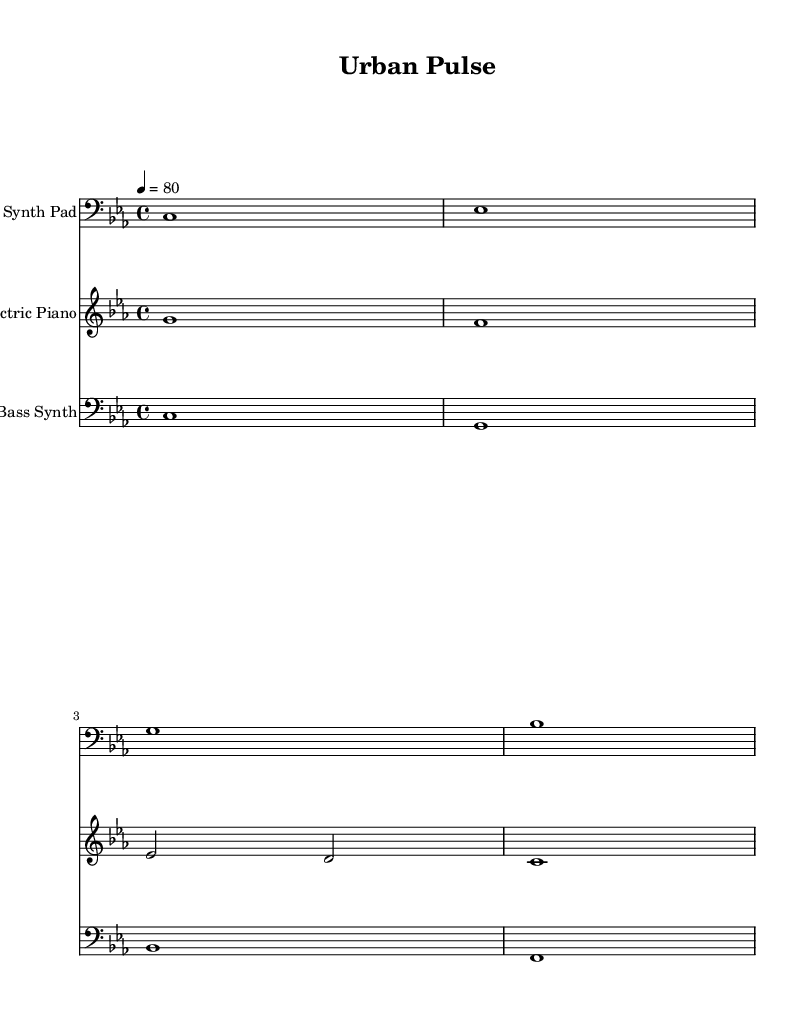What is the key signature of this music? The key signature is C minor, which has three flats (B flat, E flat, and A flat). This can be identified by looking at the key signature at the beginning of the staff.
Answer: C minor What is the time signature of this music? The time signature is 4/4, which indicates that there are four beats in each measure and the quarter note gets one beat. This can be seen near the beginning of the sheet music.
Answer: 4/4 What is the tempo marking of this music? The tempo marking is 80 beats per minute, which indicates the speed at which the piece is intended to be played. This is stated at the beginning of the score next to the tempo indication.
Answer: 80 How many distinct instruments are featured in this piece? There are three distinct instruments featured: Synth Pad, Electric Piano, and Bass Synth. This can be confirmed by examining the labeled staves in the score.
Answer: Three Which staff has the highest pitch range? The Electric Piano has the highest pitch range among the three instruments. This can be reasoned from the clefs used, with the treble clef indicating higher pitches, as compared to the bass clef used for the Synth Pad and Bass Synth.
Answer: Electric Piano What is the last note played by the Electric Piano? The last note played by the Electric Piano is C. This can be determined by looking at the notes written in the staff specifically for the Electric Piano, noting the final note in its sequence.
Answer: C Which instrument plays the note C in the first measure? The Synth Pad plays the note C in the first measure. This is confirmed by looking at the notes for each instrument in the first measure and identifying which one played C.
Answer: Synth Pad 